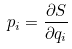Convert formula to latex. <formula><loc_0><loc_0><loc_500><loc_500>p _ { i } = \frac { \partial S } { \partial q _ { i } }</formula> 